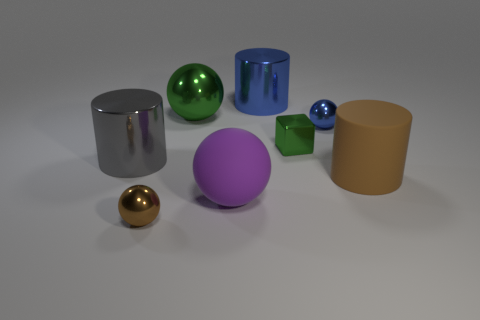Is the color of the cube the same as the rubber cylinder?
Your answer should be compact. No. Is the number of tiny cyan things greater than the number of large purple spheres?
Make the answer very short. No. How many other objects are the same material as the small green block?
Offer a terse response. 5. What number of things are large cyan things or cylinders that are in front of the blue shiny cylinder?
Provide a succinct answer. 2. Is the number of big brown matte objects less than the number of tiny balls?
Make the answer very short. Yes. What color is the matte object to the right of the tiny metal sphere behind the brown object that is to the right of the small green metal thing?
Keep it short and to the point. Brown. Is the large gray cylinder made of the same material as the large green thing?
Give a very brief answer. Yes. There is a matte sphere; what number of rubber cylinders are on the right side of it?
Ensure brevity in your answer.  1. The blue thing that is the same shape as the big purple rubber object is what size?
Make the answer very short. Small. What number of blue objects are large shiny objects or tiny metallic things?
Offer a terse response. 2. 